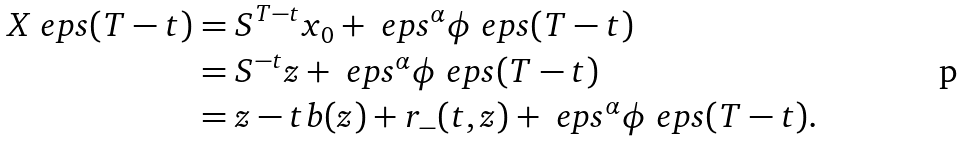<formula> <loc_0><loc_0><loc_500><loc_500>X _ { \ } e p s ( T - t ) & = S ^ { T - t } x _ { 0 } + \ e p s ^ { \alpha } \phi _ { \ } e p s ( T - t ) \\ & = S ^ { - t } z + \ e p s ^ { \alpha } \phi _ { \ } e p s ( T - t ) \\ & = z - t b ( z ) + r _ { - } ( t , z ) + \ e p s ^ { \alpha } \phi _ { \ } e p s ( T - t ) .</formula> 